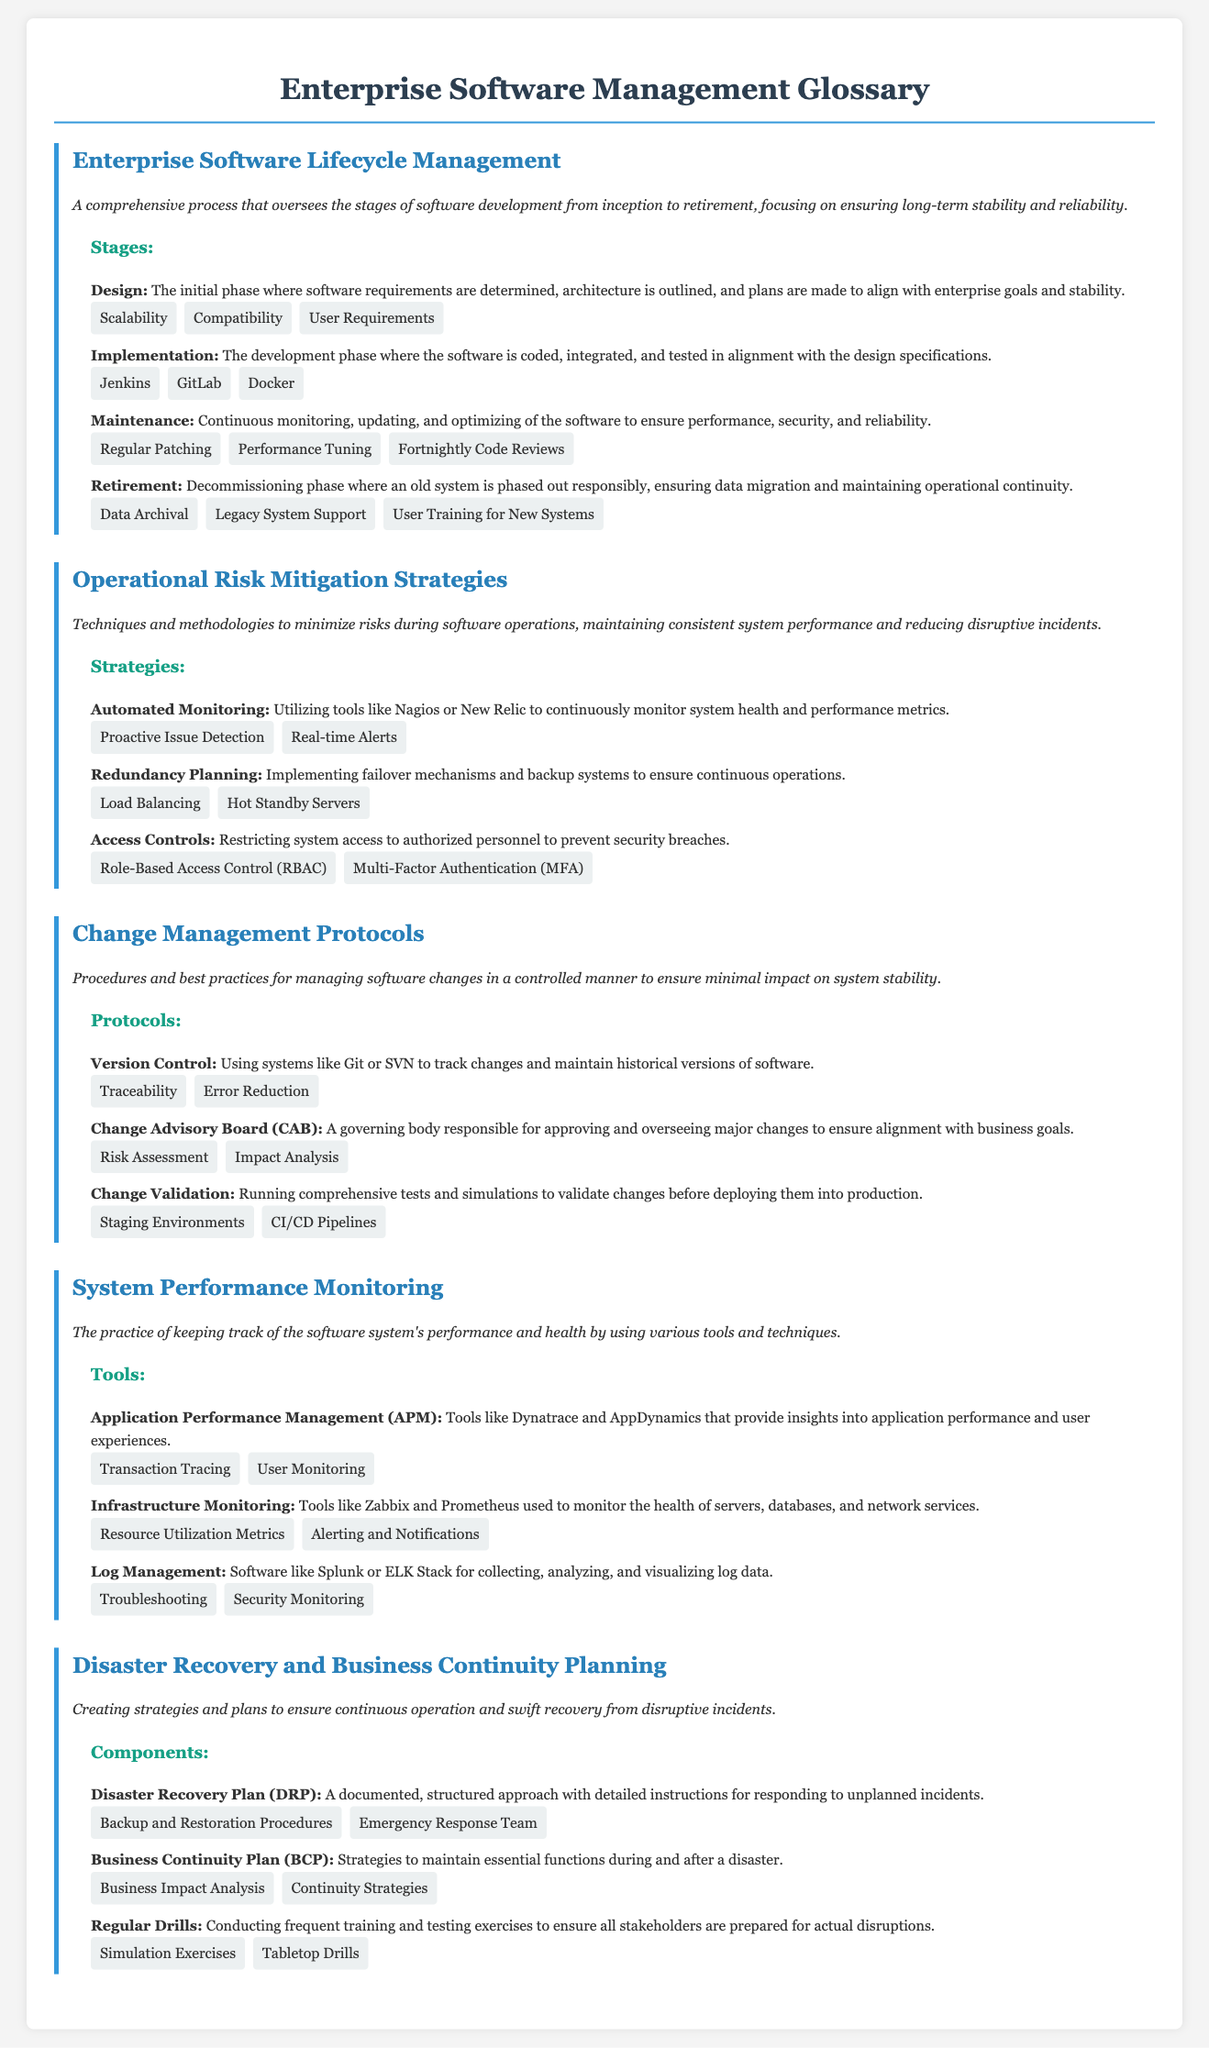What is the focus of Enterprise Software Lifecycle Management? The focus of Enterprise Software Lifecycle Management is to ensure long-term stability and reliability of software systems from inception to retirement.
Answer: long-term stability and reliability What tool is mentioned for Automated Monitoring? The document mentions Nagios or New Relic as tools utilized for automated monitoring of system health and performance metrics.
Answer: Nagios or New Relic What is the purpose of a Change Advisory Board? The Change Advisory Board is responsible for approving and overseeing major changes to ensure alignment with business goals and stability.
Answer: approving and overseeing major changes What is one of the key items listed under Maintenance? Regular Patching is one of the key items listed as part of the Maintenance stage in lifecycle management.
Answer: Regular Patching What does a Disaster Recovery Plan provide? A Disaster Recovery Plan provides a documented and structured approach with detailed instructions for responding to unplanned incidents.
Answer: detailed instructions for responding to unplanned incidents What kind of analysis is utilized in Business Continuity Planning? Business Impact Analysis is utilized in Business Continuity Planning to determine critical functions and resources.
Answer: Business Impact Analysis What is emphasized in the Change Management Protocols section? The Change Management Protocols section emphasizes managing software changes in a controlled manner.
Answer: managing software changes in a controlled manner How often should Regular Drills be conducted? Regular Drills should be conducted frequently to ensure preparedness for disruptions.
Answer: frequently What is one example of a key item under Redundancy Planning? Load Balancing is an example of a key item under Redundancy Planning to ensure continuous operations.
Answer: Load Balancing 